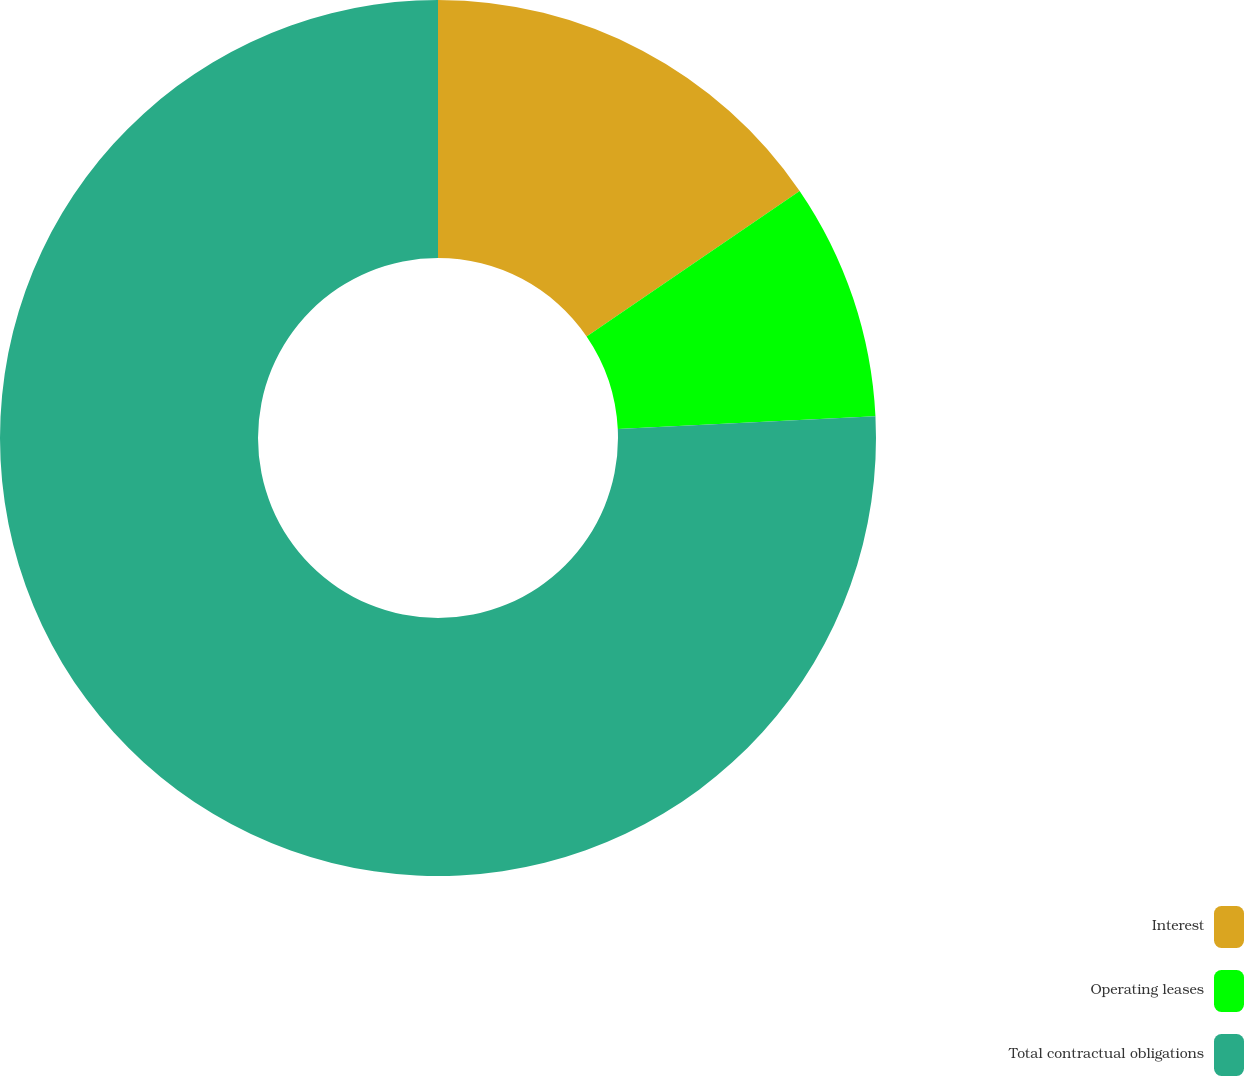<chart> <loc_0><loc_0><loc_500><loc_500><pie_chart><fcel>Interest<fcel>Operating leases<fcel>Total contractual obligations<nl><fcel>15.46%<fcel>8.75%<fcel>75.79%<nl></chart> 